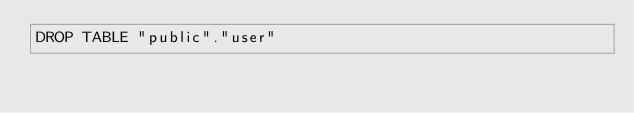Convert code to text. <code><loc_0><loc_0><loc_500><loc_500><_SQL_>DROP TABLE "public"."user"
</code> 